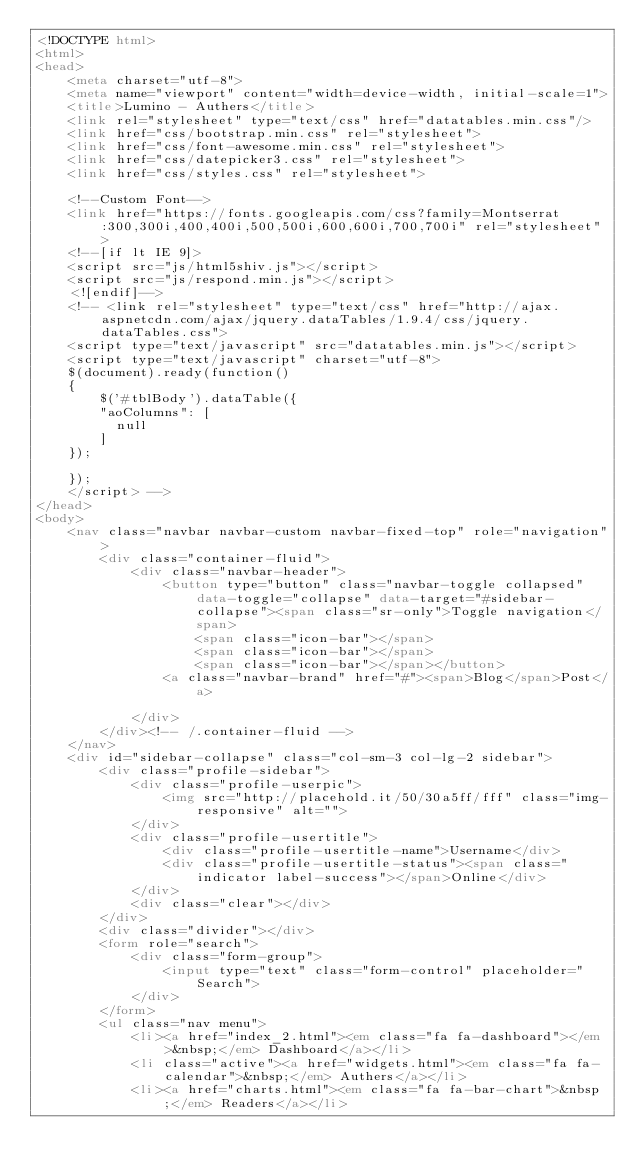<code> <loc_0><loc_0><loc_500><loc_500><_HTML_><!DOCTYPE html>
<html>
<head>
	<meta charset="utf-8">
	<meta name="viewport" content="width=device-width, initial-scale=1">
	<title>Lumino - Authers</title>
	<link rel="stylesheet" type="text/css" href="datatables.min.css"/>
	<link href="css/bootstrap.min.css" rel="stylesheet">
	<link href="css/font-awesome.min.css" rel="stylesheet">
	<link href="css/datepicker3.css" rel="stylesheet">
	<link href="css/styles.css" rel="stylesheet">
	
	<!--Custom Font-->
	<link href="https://fonts.googleapis.com/css?family=Montserrat:300,300i,400,400i,500,500i,600,600i,700,700i" rel="stylesheet">
	<!--[if lt IE 9]>
	<script src="js/html5shiv.js"></script>
	<script src="js/respond.min.js"></script>
	<![endif]-->
	<!-- <link rel="stylesheet" type="text/css" href="http://ajax.aspnetcdn.com/ajax/jquery.dataTables/1.9.4/css/jquery.dataTables.css">
	<script type="text/javascript" src="datatables.min.js"></script>
	<script type="text/javascript" charset="utf-8">
	$(document).ready(function() 
	{
		$('#tblBody').dataTable({
        "aoColumns": [
          null
        ]
    });   

	});
	</script> -->
</head>
<body>
	<nav class="navbar navbar-custom navbar-fixed-top" role="navigation">
		<div class="container-fluid">
			<div class="navbar-header">
				<button type="button" class="navbar-toggle collapsed" data-toggle="collapse" data-target="#sidebar-collapse"><span class="sr-only">Toggle navigation</span>
					<span class="icon-bar"></span>
					<span class="icon-bar"></span>
					<span class="icon-bar"></span></button>
				<a class="navbar-brand" href="#"><span>Blog</span>Post</a>
			
			</div>
		</div><!-- /.container-fluid -->
	</nav>
	<div id="sidebar-collapse" class="col-sm-3 col-lg-2 sidebar">
		<div class="profile-sidebar">
			<div class="profile-userpic">
				<img src="http://placehold.it/50/30a5ff/fff" class="img-responsive" alt="">
			</div>
			<div class="profile-usertitle">
				<div class="profile-usertitle-name">Username</div>
				<div class="profile-usertitle-status"><span class="indicator label-success"></span>Online</div>
			</div>
			<div class="clear"></div>
		</div>
		<div class="divider"></div>
		<form role="search">
			<div class="form-group">
				<input type="text" class="form-control" placeholder="Search">
			</div>
		</form>
		<ul class="nav menu">
			<li><a href="index_2.html"><em class="fa fa-dashboard"></em>&nbsp;</em> Dashboard</a></li>
			<li class="active"><a href="widgets.html"><em class="fa fa-calendar">&nbsp;</em> Authers</a></li>
			<li><a href="charts.html"><em class="fa fa-bar-chart">&nbsp;</em> Readers</a></li></code> 